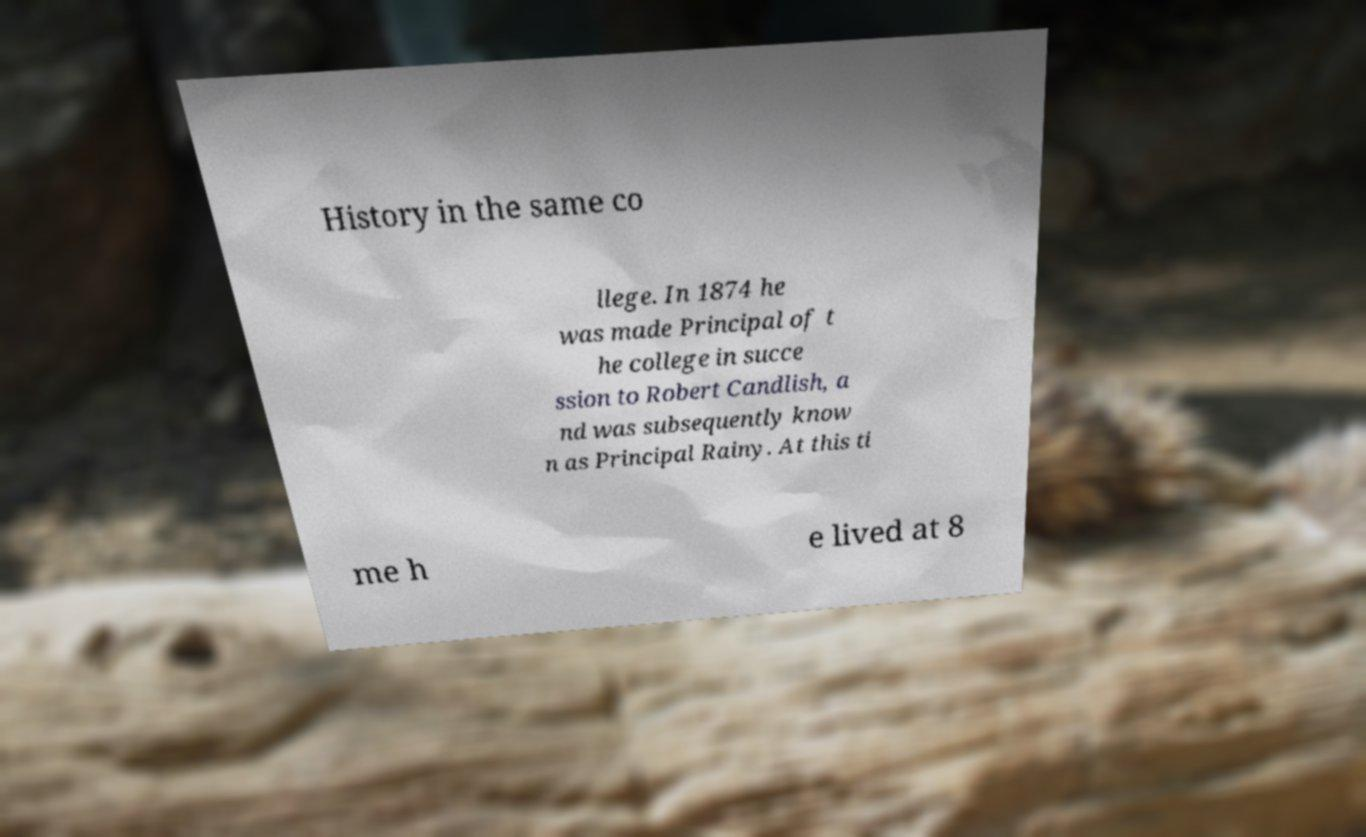Could you assist in decoding the text presented in this image and type it out clearly? History in the same co llege. In 1874 he was made Principal of t he college in succe ssion to Robert Candlish, a nd was subsequently know n as Principal Rainy. At this ti me h e lived at 8 